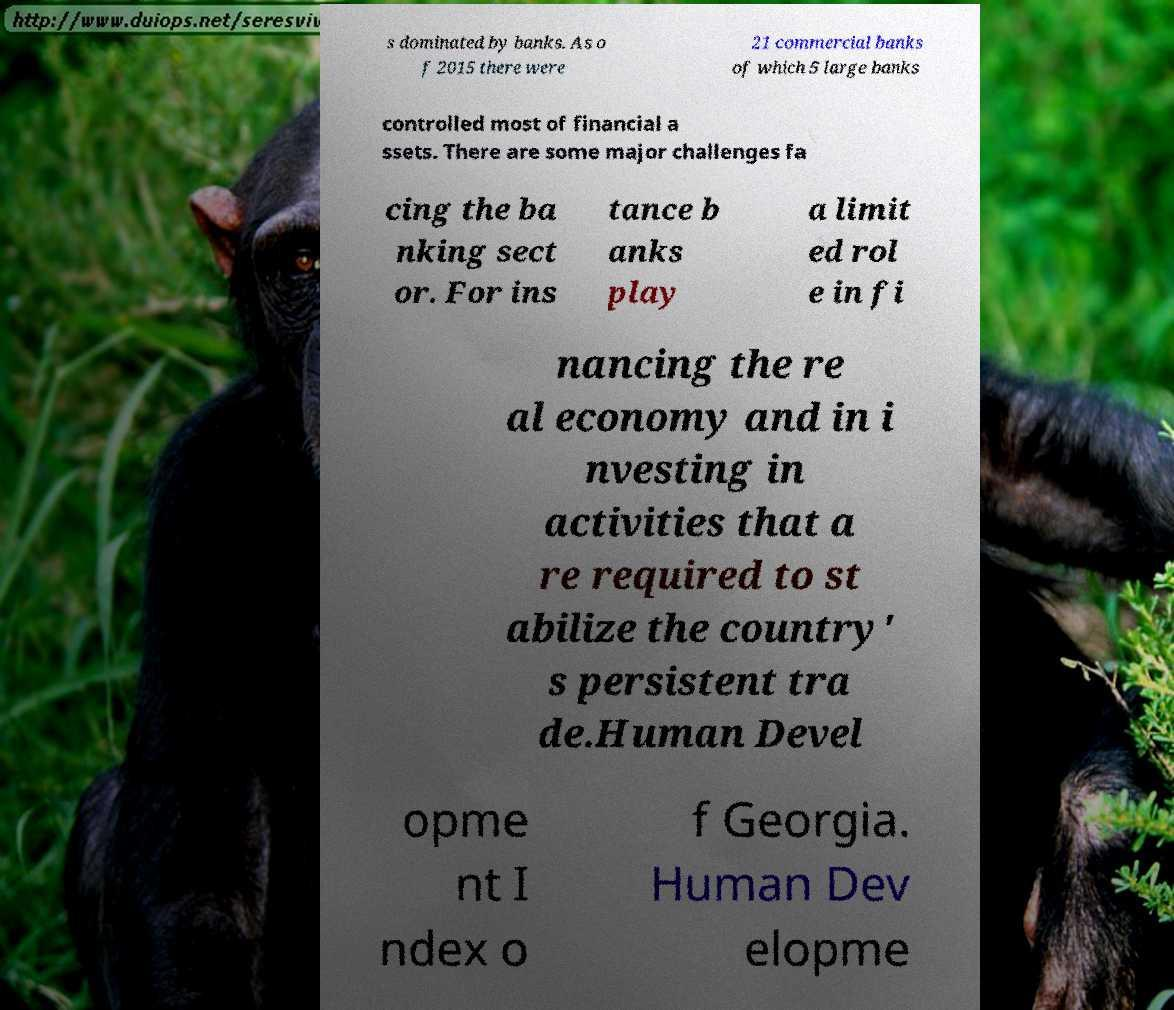Can you read and provide the text displayed in the image?This photo seems to have some interesting text. Can you extract and type it out for me? s dominated by banks. As o f 2015 there were 21 commercial banks of which 5 large banks controlled most of financial a ssets. There are some major challenges fa cing the ba nking sect or. For ins tance b anks play a limit ed rol e in fi nancing the re al economy and in i nvesting in activities that a re required to st abilize the country' s persistent tra de.Human Devel opme nt I ndex o f Georgia. Human Dev elopme 